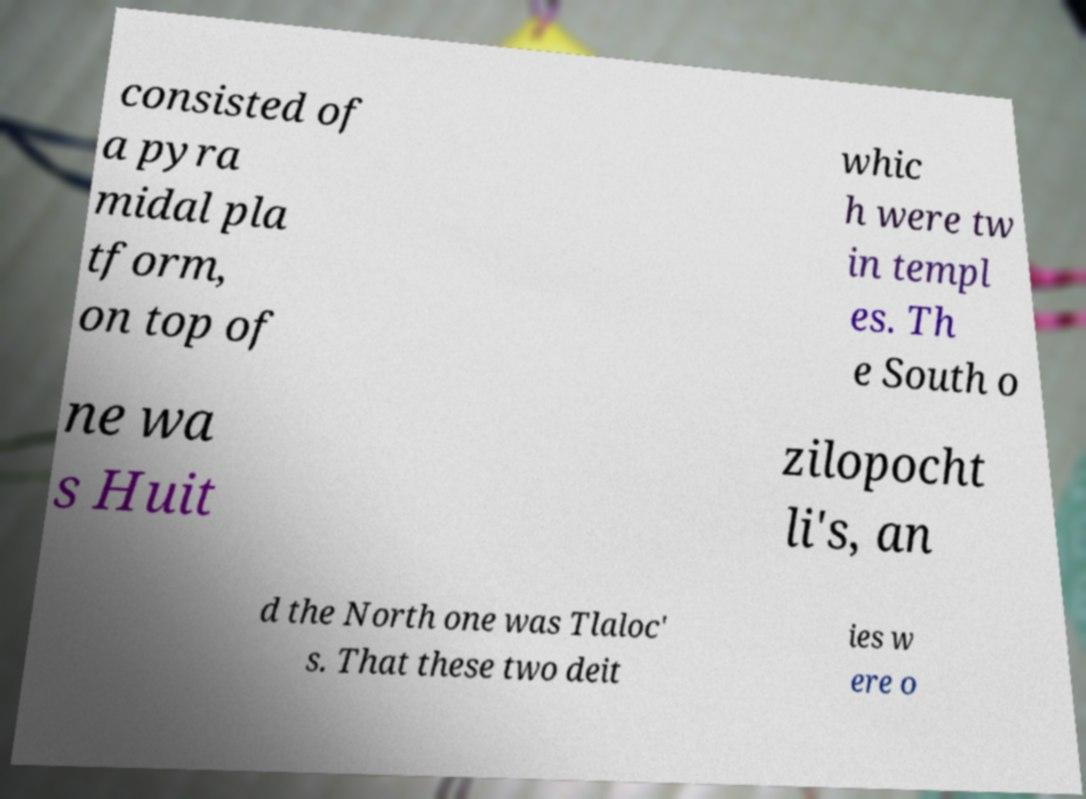What messages or text are displayed in this image? I need them in a readable, typed format. consisted of a pyra midal pla tform, on top of whic h were tw in templ es. Th e South o ne wa s Huit zilopocht li's, an d the North one was Tlaloc' s. That these two deit ies w ere o 